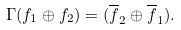<formula> <loc_0><loc_0><loc_500><loc_500>\Gamma ( f _ { 1 } \oplus f _ { 2 } ) = ( \overline { f } _ { 2 } \oplus \overline { f } _ { 1 } ) .</formula> 